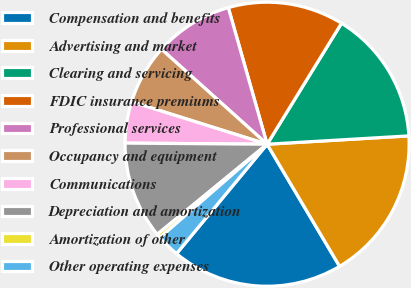Convert chart to OTSL. <chart><loc_0><loc_0><loc_500><loc_500><pie_chart><fcel>Compensation and benefits<fcel>Advertising and market<fcel>Clearing and servicing<fcel>FDIC insurance premiums<fcel>Professional services<fcel>Occupancy and equipment<fcel>Communications<fcel>Depreciation and amortization<fcel>Amortization of other<fcel>Other operating expenses<nl><fcel>19.53%<fcel>17.41%<fcel>15.29%<fcel>13.18%<fcel>8.94%<fcel>6.82%<fcel>4.71%<fcel>11.06%<fcel>0.47%<fcel>2.59%<nl></chart> 